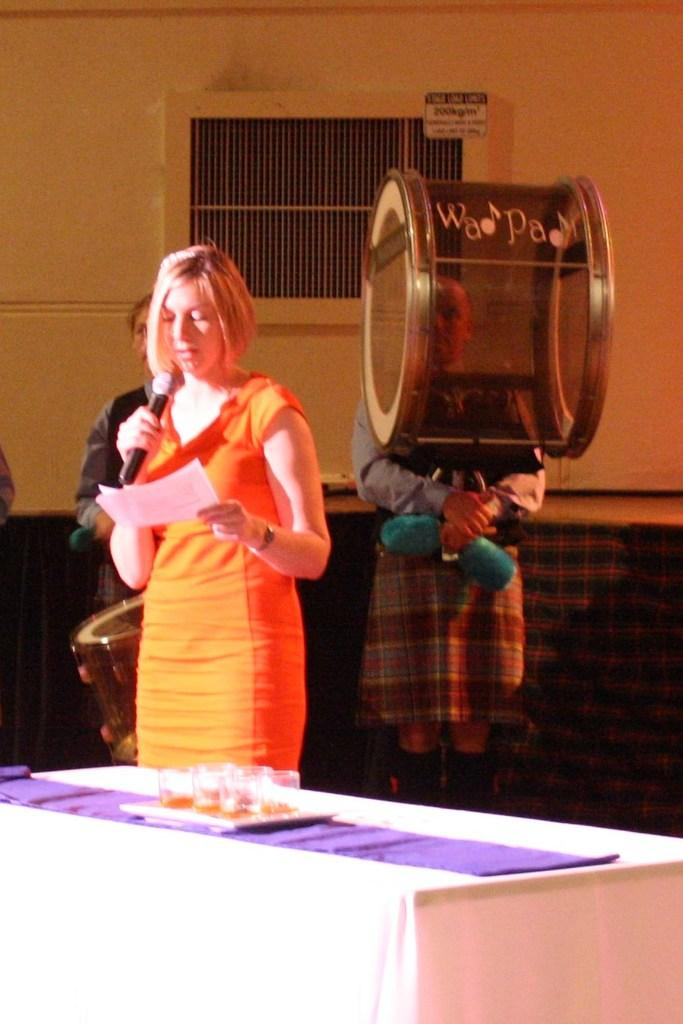What type of structure can be seen in the image? There is a wall in the image. Is there any opening in the wall? Yes, there is a window in the image. What object is related to music in the image? There is a drum in the image. How many people are present in the image? There are three people standing in the image. What piece of furniture is in the image? There is a table in the image. What can be found on the table? There are glasses on the table. Can you see any part of a bird in the image? There is no bird present in the image. Is there a cobweb visible on the wall in the image? The presence of a cobweb is not mentioned in the provided facts, so it cannot be confirmed or denied. 